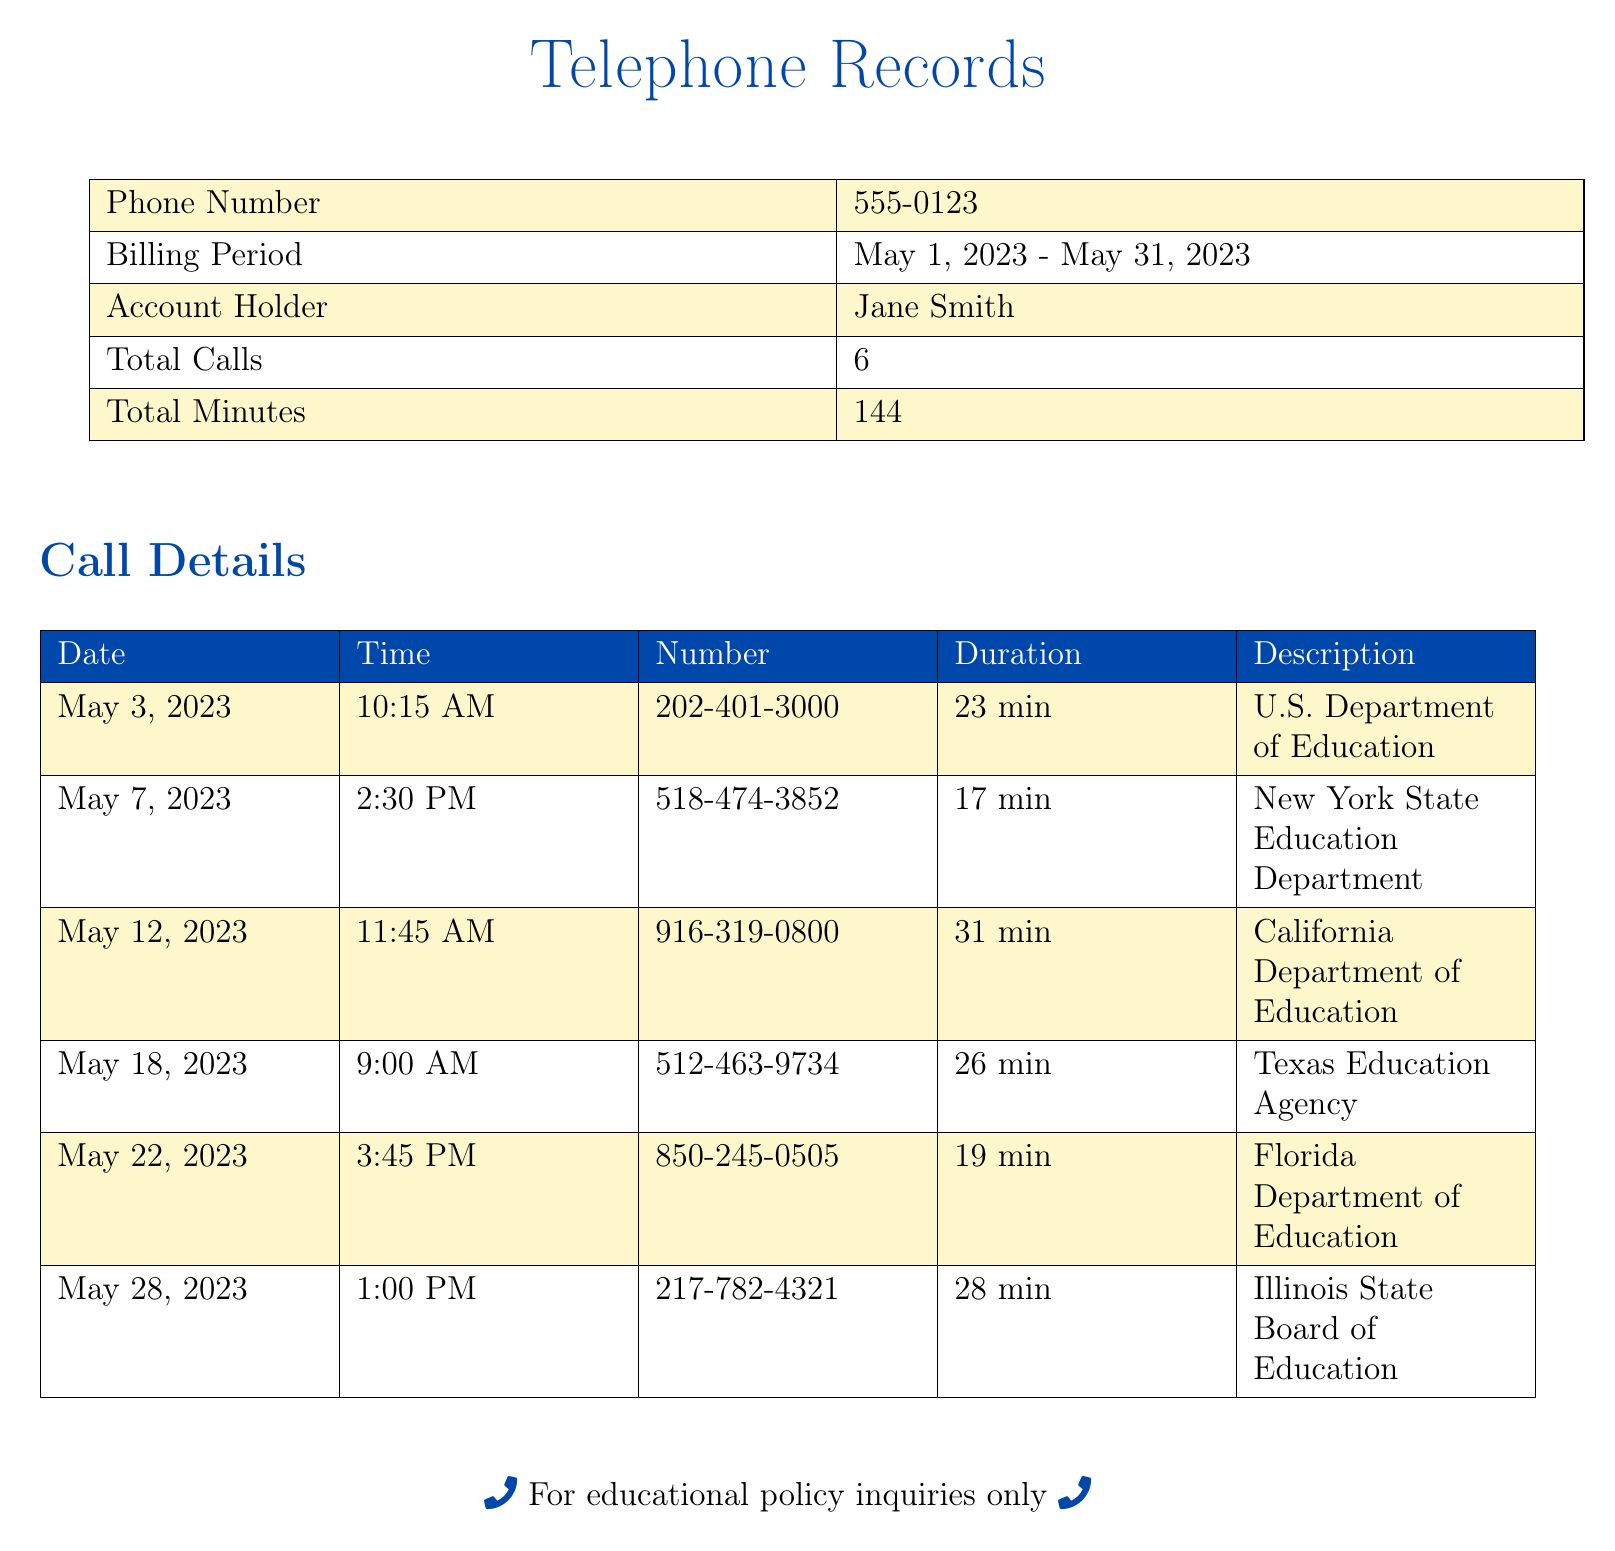what is the account holder's name? The account holder's name listed in the document is Jane Smith.
Answer: Jane Smith how many total calls were made? The document states the total number of calls is 6.
Answer: 6 what was the duration of the call to the California Department of Education? The duration of the call on May 12, 2023, to the California Department of Education is 31 minutes.
Answer: 31 min which educational department was contacted on May 18, 2023? The document shows that the Texas Education Agency was contacted on this date.
Answer: Texas Education Agency what is the total number of minutes spent on calls? The total minutes spent on calls is mentioned as 144 in the document.
Answer: 144 which phone number was called on May 7, 2023? The phone number called on this date is 518-474-3852, according to the record.
Answer: 518-474-3852 how many minutes was the shortest call? The shortest call duration is noted in the record as 17 minutes.
Answer: 17 min what is the billing period for the calls? The billing period for the calls indicated in the document is from May 1, 2023, to May 31, 2023.
Answer: May 1, 2023 - May 31, 2023 